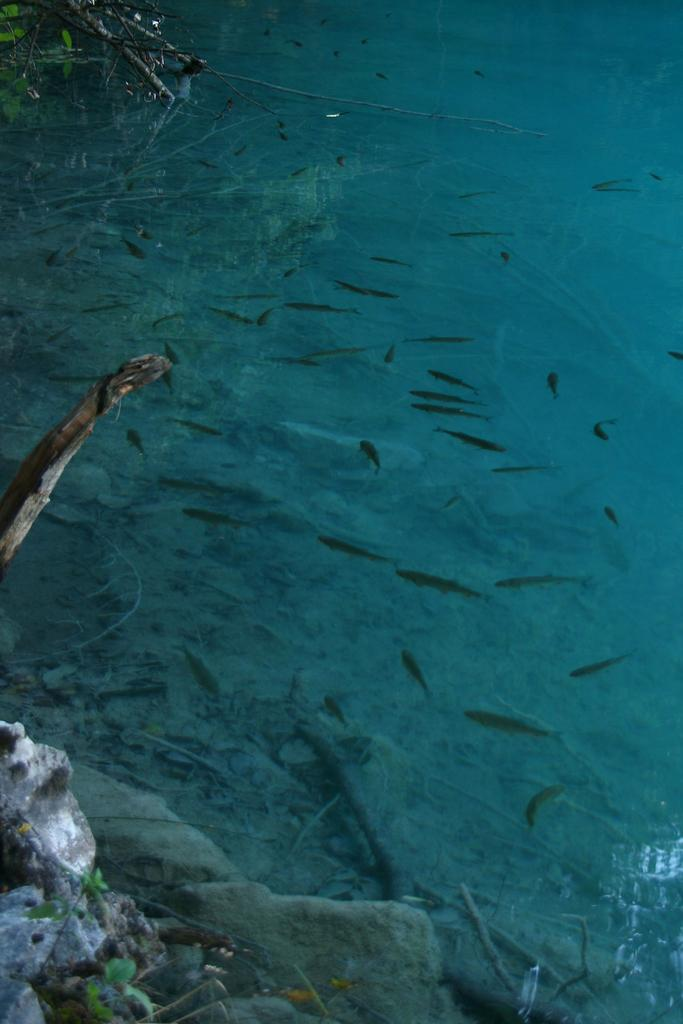What type of animals can be seen in the image? There are fish in the water. What other elements can be seen in the image besides the fish? There are stems, leaves, and stones in the image. What type of flag is visible in the image? There is no flag present in the image. How many passengers are visible in the image? There are no passengers present in the image. 